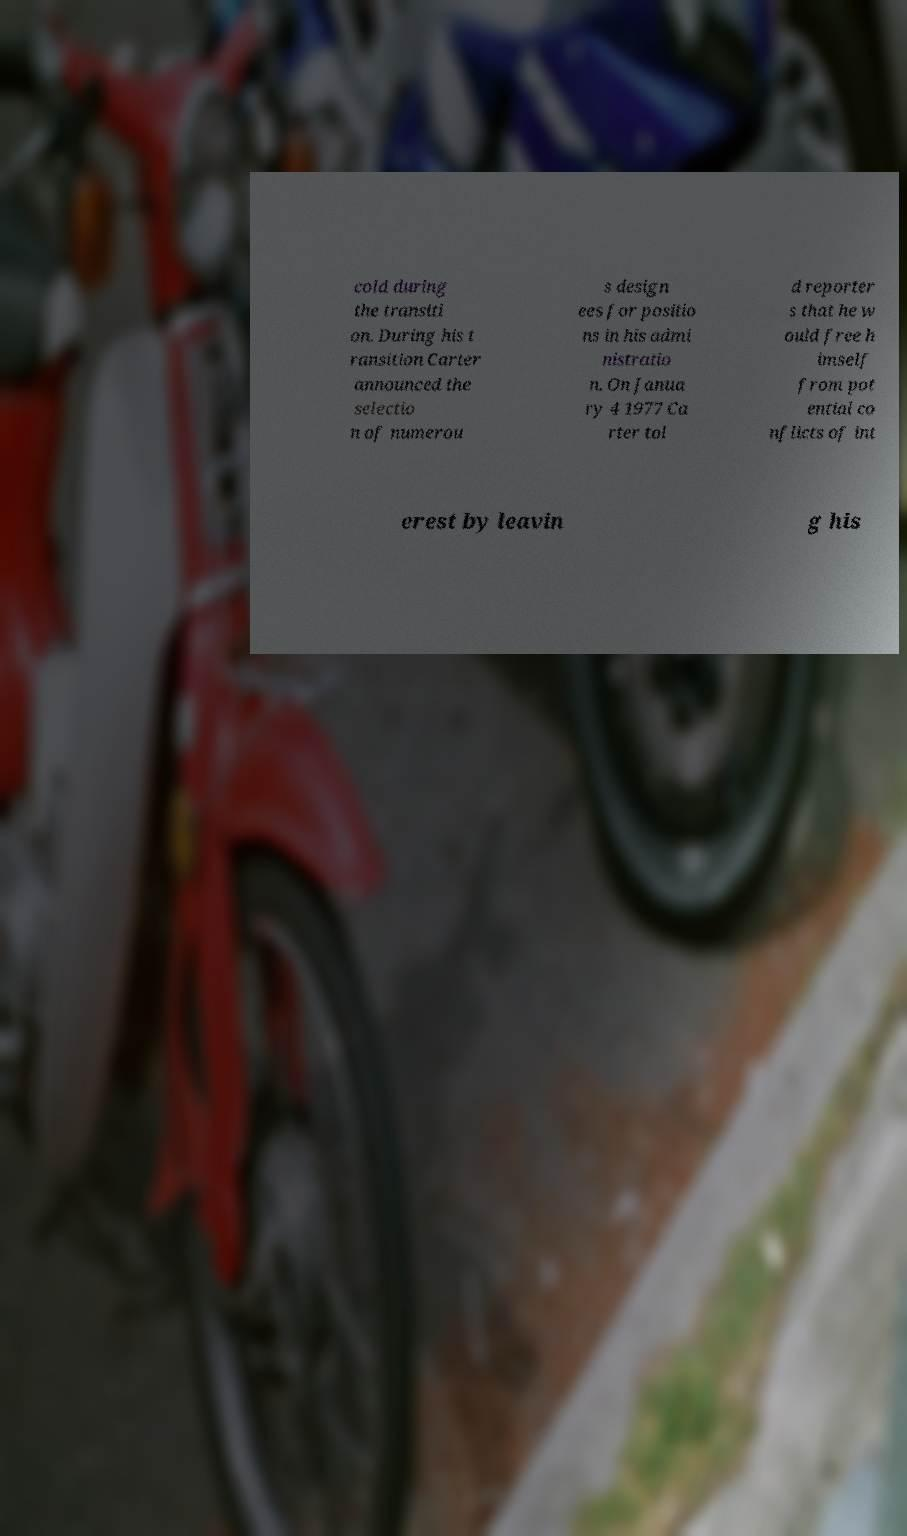What messages or text are displayed in this image? I need them in a readable, typed format. cold during the transiti on. During his t ransition Carter announced the selectio n of numerou s design ees for positio ns in his admi nistratio n. On Janua ry 4 1977 Ca rter tol d reporter s that he w ould free h imself from pot ential co nflicts of int erest by leavin g his 